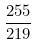<formula> <loc_0><loc_0><loc_500><loc_500>\frac { 2 5 5 } { 2 1 9 }</formula> 